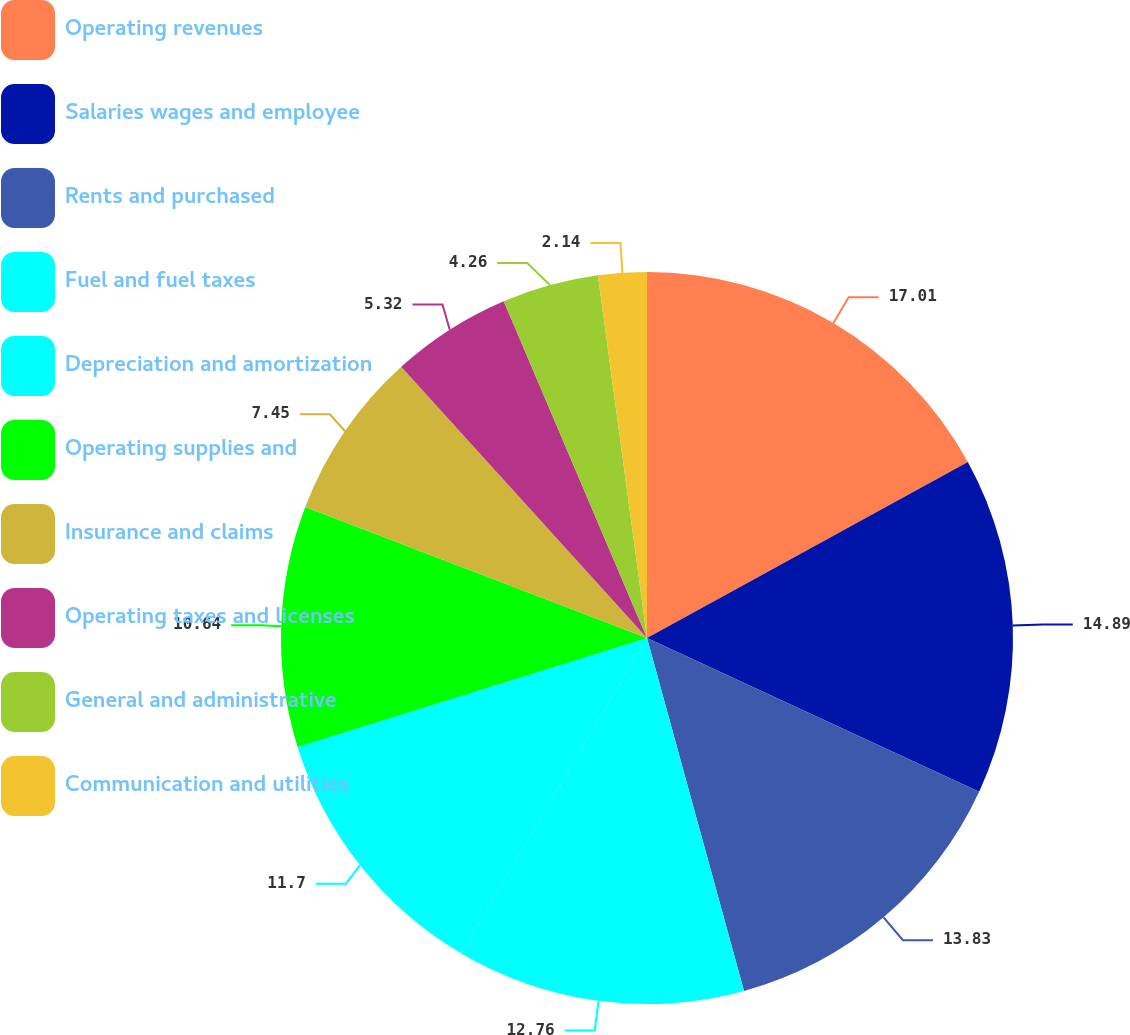Convert chart to OTSL. <chart><loc_0><loc_0><loc_500><loc_500><pie_chart><fcel>Operating revenues<fcel>Salaries wages and employee<fcel>Rents and purchased<fcel>Fuel and fuel taxes<fcel>Depreciation and amortization<fcel>Operating supplies and<fcel>Insurance and claims<fcel>Operating taxes and licenses<fcel>General and administrative<fcel>Communication and utilities<nl><fcel>17.01%<fcel>14.89%<fcel>13.83%<fcel>12.76%<fcel>11.7%<fcel>10.64%<fcel>7.45%<fcel>5.32%<fcel>4.26%<fcel>2.14%<nl></chart> 